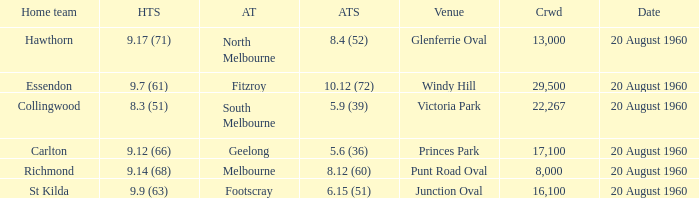What is the crowd size of the game when Fitzroy is the away team? 1.0. 